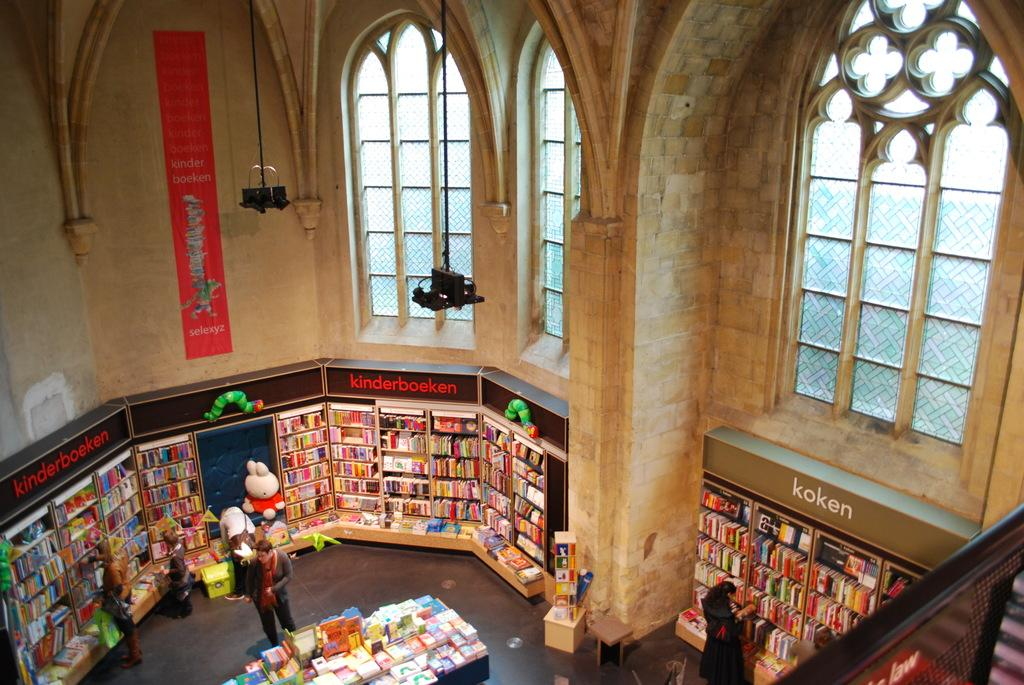<image>
Create a compact narrative representing the image presented. the word koken is on some books in a library 